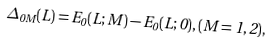Convert formula to latex. <formula><loc_0><loc_0><loc_500><loc_500>\Delta _ { 0 M } ( L ) = E _ { 0 } ( L ; M ) - E _ { 0 } ( L ; 0 ) , ( M = 1 , 2 ) ,</formula> 